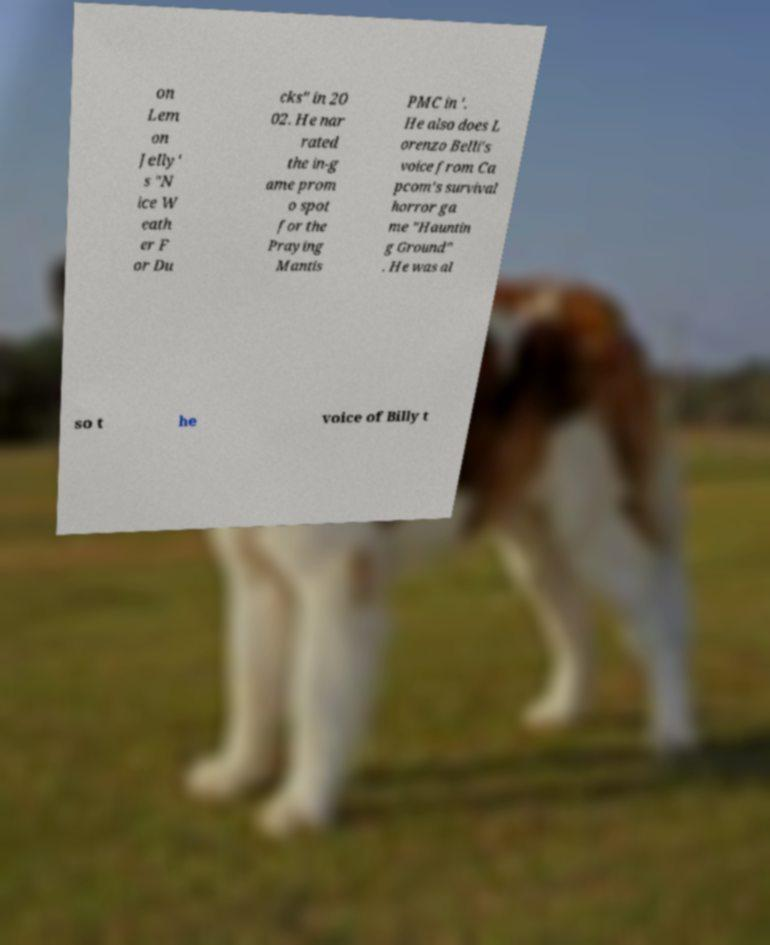Can you read and provide the text displayed in the image?This photo seems to have some interesting text. Can you extract and type it out for me? on Lem on Jelly' s "N ice W eath er F or Du cks" in 20 02. He nar rated the in-g ame prom o spot for the Praying Mantis PMC in '. He also does L orenzo Belli's voice from Ca pcom's survival horror ga me "Hauntin g Ground" . He was al so t he voice of Billy t 